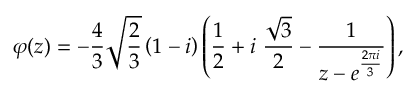Convert formula to latex. <formula><loc_0><loc_0><loc_500><loc_500>\varphi ( z ) = - \frac { 4 } { 3 } \sqrt { \frac { 2 } { 3 } } \left ( 1 - i \right ) \left ( \frac { 1 } { 2 } + i \ \frac { \sqrt { 3 } } { 2 } - \frac { 1 } { z - e ^ { \frac { 2 \pi i } { 3 } } } \right ) ,</formula> 